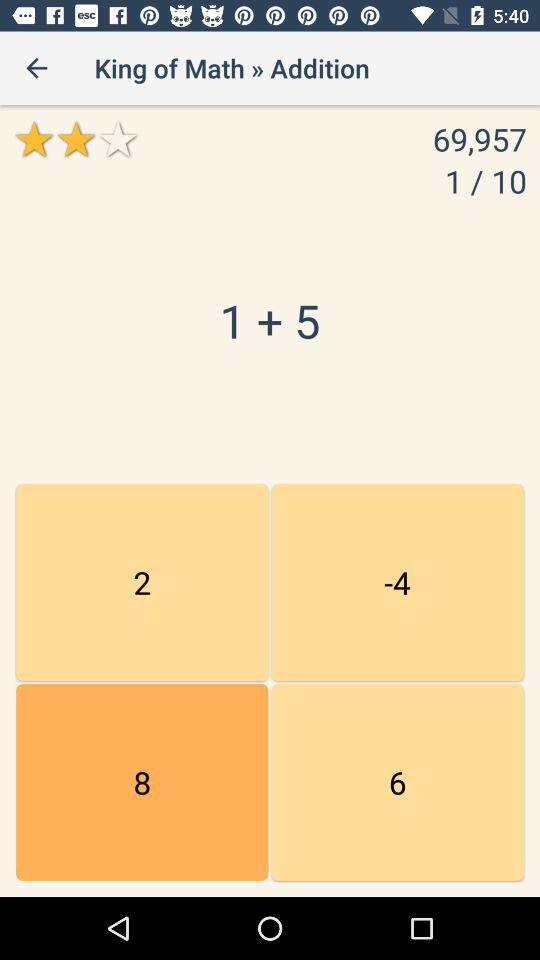Which page number is currently shown on the screen? The page number currently shown on the screen is 1. 